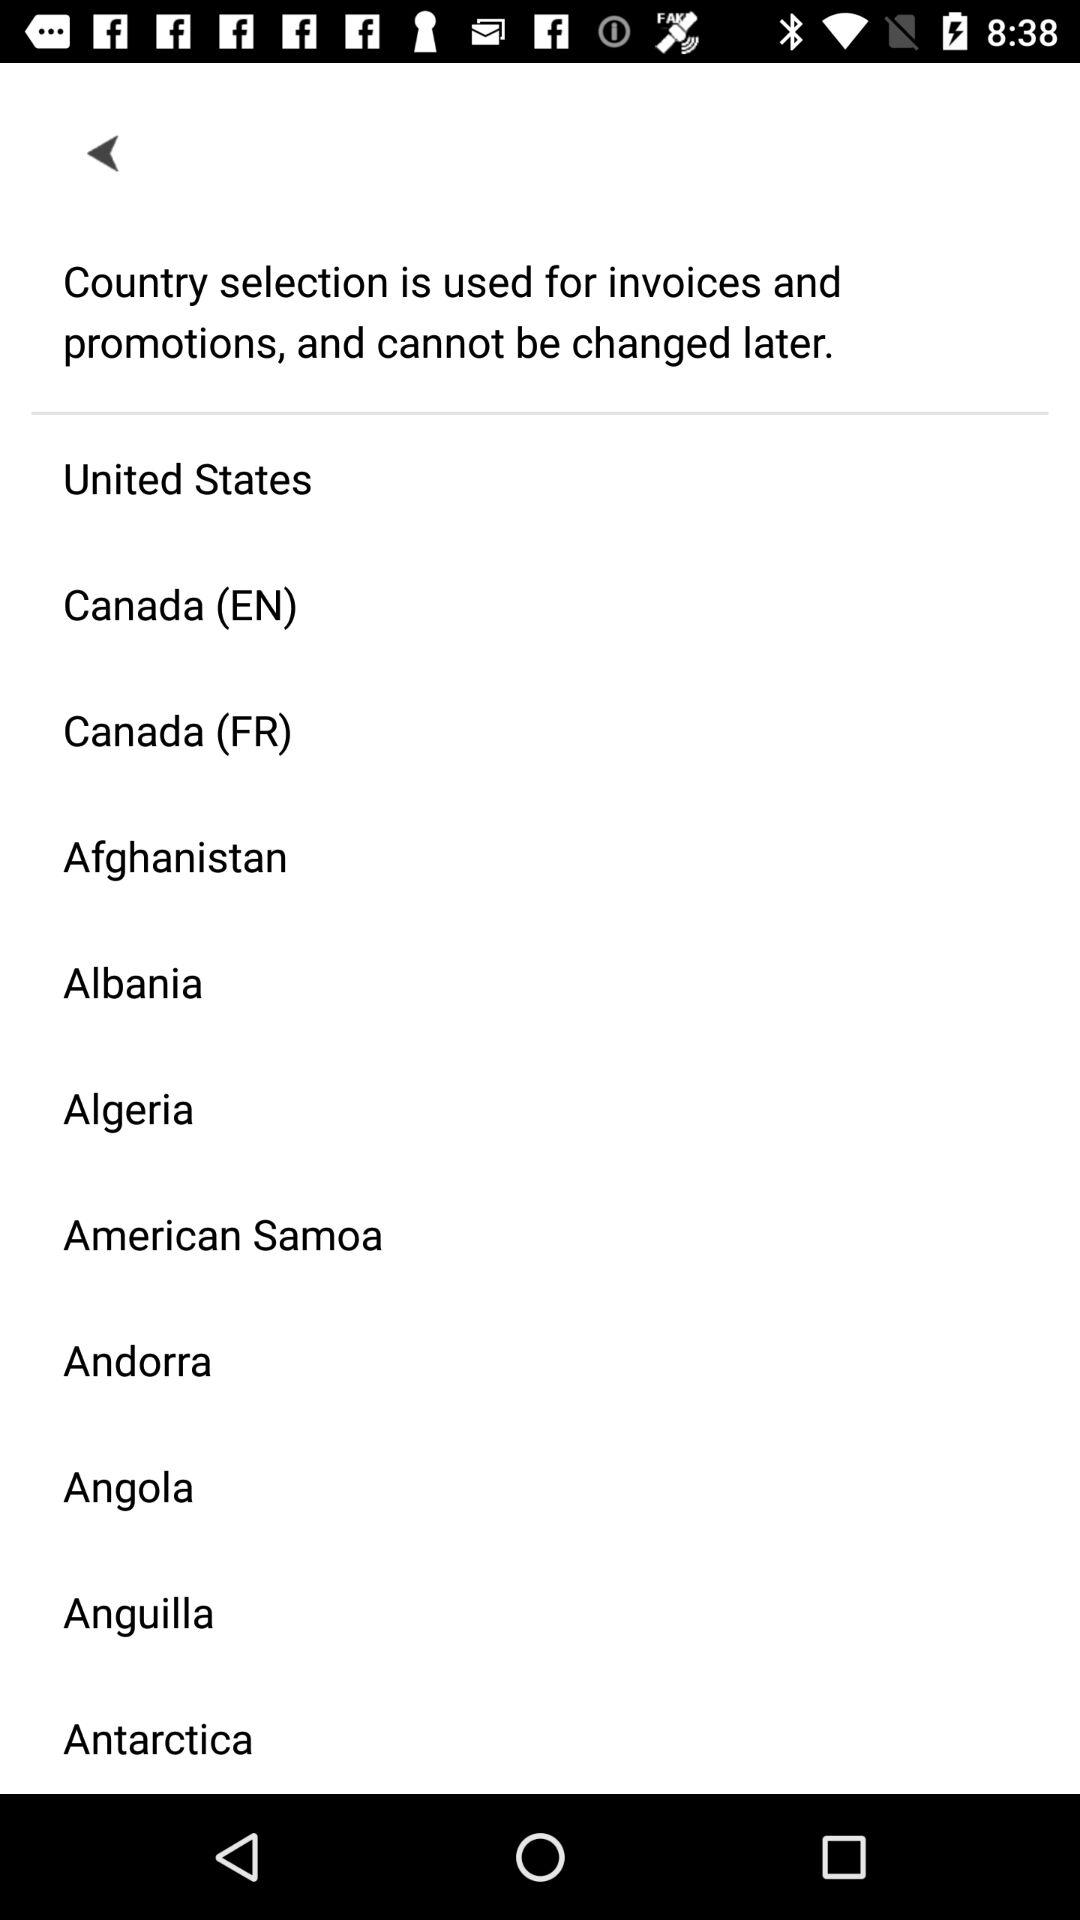Can we change the selected country later? You cannot change the selected country later. 